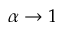<formula> <loc_0><loc_0><loc_500><loc_500>\alpha \rightarrow 1</formula> 